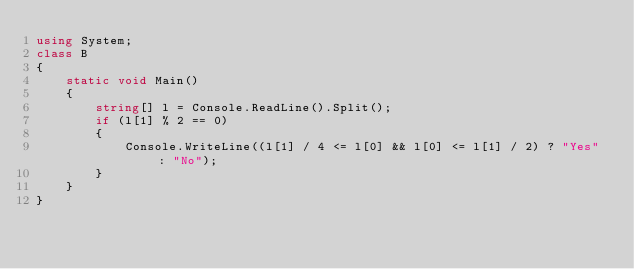Convert code to text. <code><loc_0><loc_0><loc_500><loc_500><_C#_>using System;
class B
{
    static void Main()
    {
        string[] l = Console.ReadLine().Split();
        if (l[1] % 2 == 0)
        {
            Console.WriteLine((l[1] / 4 <= l[0] && l[0] <= l[1] / 2) ? "Yes" : "No");
        }
    }
}</code> 